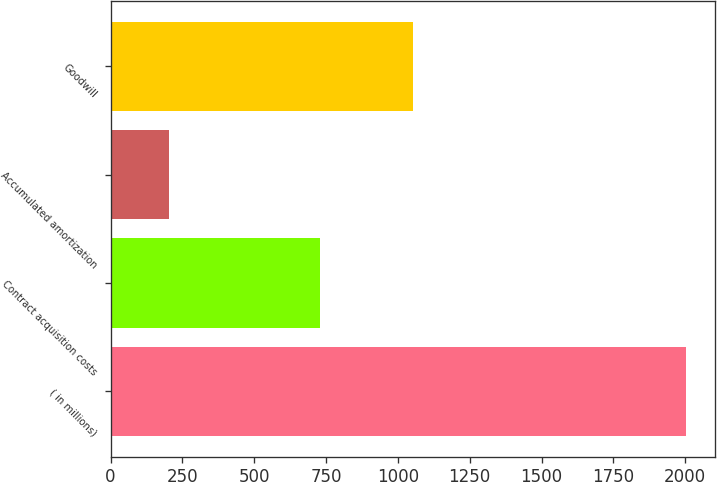Convert chart. <chart><loc_0><loc_0><loc_500><loc_500><bar_chart><fcel>( in millions)<fcel>Contract acquisition costs<fcel>Accumulated amortization<fcel>Goodwill<nl><fcel>2003<fcel>730<fcel>204<fcel>1051<nl></chart> 